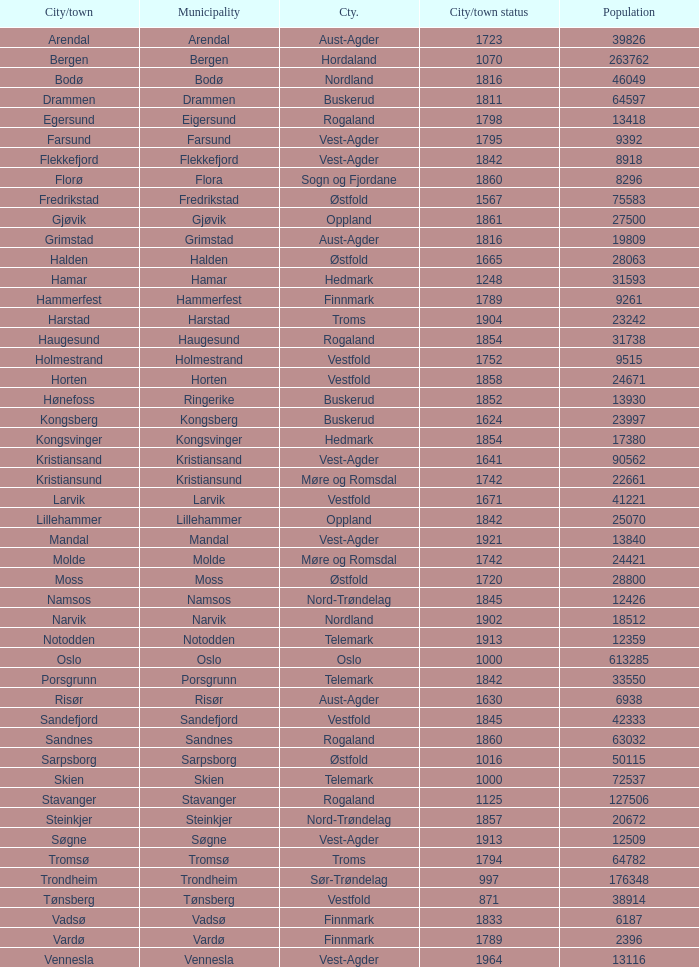Which municipality has a population of 24421? Molde. 